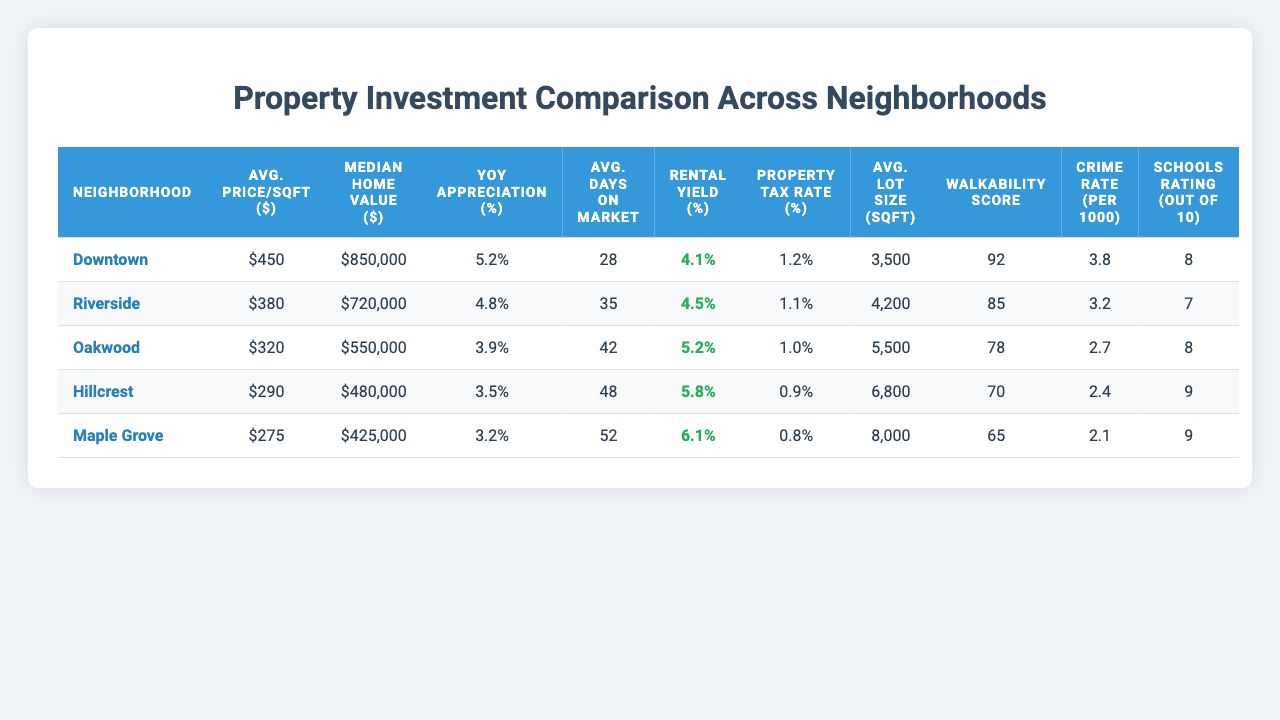What is the average price per square foot in Downtown? The table shows that the average price per square foot in Downtown is $450.
Answer: $450 Which neighborhood has the highest crime rate? By comparing the crime rates per 1000 people, Downtown has a crime rate of 3.8, Riverside 3.2, Oakwood 2.7, Hillcrest 2.4, and Maple Grove 2.1. Therefore, Downtown has the highest crime rate.
Answer: Downtown What is the median home value in Oakwood? The table indicates that the median home value in Oakwood is $550,000.
Answer: $550,000 What is the difference in average days on market between Downtown and Maple Grove? The average days on market in Downtown is 28 days and in Maple Grove is 52 days. The difference is 52 - 28 = 24 days.
Answer: 24 days Which neighborhood has the best walkability score? The walkability scores for the neighborhoods are Downtown (92), Riverside (85), Oakwood (78), Hillcrest (70), and Maple Grove (65). Downtown has the highest score of 92.
Answer: Downtown Is the rental yield percentage in Hillcrest higher than 5%? The rental yield percentage for Hillcrest is 5.8%, which is indeed higher than 5%.
Answer: Yes What is the average rental yield percentage across all neighborhoods? Summing the rental yield percentages gives (4.1 + 4.5 + 5.2 + 5.8 + 6.1) = 25.7. Dividing by the number of neighborhoods (5), the average rental yield percentage is 25.7/5 = 5.14%.
Answer: 5.14% Which neighborhood has the lowest property tax rate? The property tax rates listed are 1.2% for Downtown, 1.1% for Riverside, 1.0% for Oakwood, 0.9% for Hillcrest, and 0.8% for Maple Grove. Maple Grove has the lowest property tax rate at 0.8%.
Answer: Maple Grove What is the year-over-year appreciation rate for Oakwood compared to Hillcrest? Oakwood has a year-over-year appreciation of 3.9% and Hillcrest has 3.5%. Comparing the two, Oakwood's appreciation rate is higher by 3.9% - 3.5% = 0.4%.
Answer: 0.4% Are the schools in Maple Grove rated higher than those in Riverside? Maple Grove and Riverside have school ratings of 9 and 7 respectively. Since 9 is higher than 7, the statement is true.
Answer: Yes If you combine the average lot sizes of Downtown and Riverside, what is the total? The average lot sizes are 3500 sqft for Downtown and 4200 sqft for Riverside. Adding these gives 3500 + 4200 = 7700 sqft.
Answer: 7700 sqft 